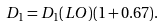<formula> <loc_0><loc_0><loc_500><loc_500>D _ { 1 } = D _ { 1 } ( L O ) ( 1 + 0 . 6 7 ) .</formula> 